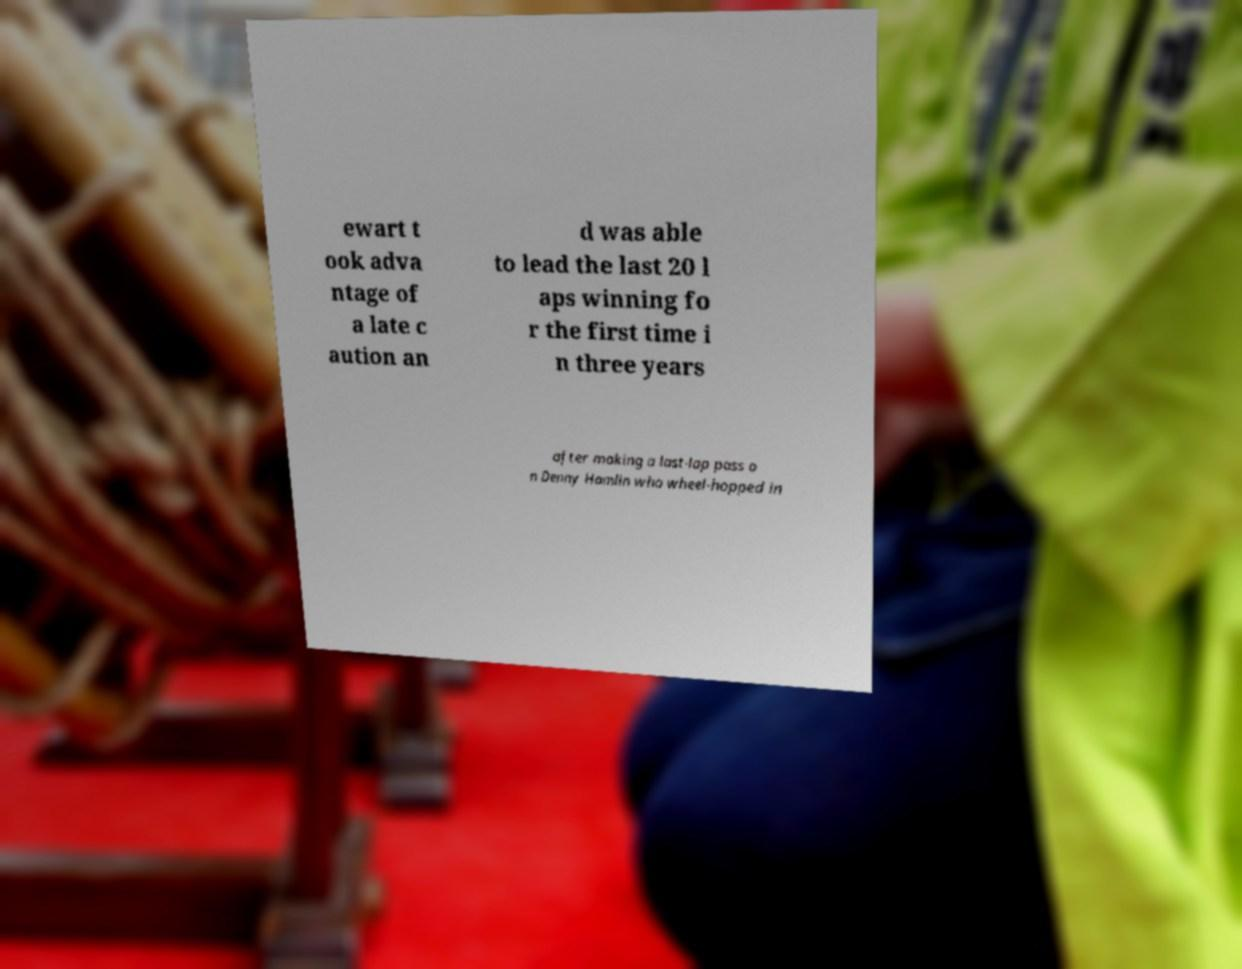Please read and relay the text visible in this image. What does it say? ewart t ook adva ntage of a late c aution an d was able to lead the last 20 l aps winning fo r the first time i n three years after making a last-lap pass o n Denny Hamlin who wheel-hopped in 